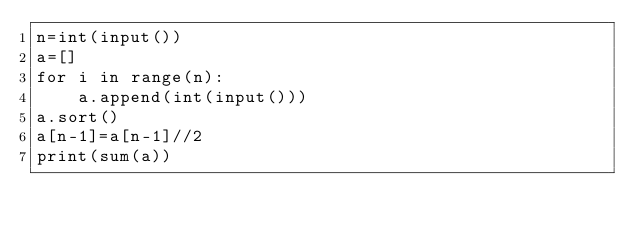<code> <loc_0><loc_0><loc_500><loc_500><_Python_>n=int(input())
a=[]
for i in range(n):
    a.append(int(input()))
a.sort()
a[n-1]=a[n-1]//2
print(sum(a))</code> 